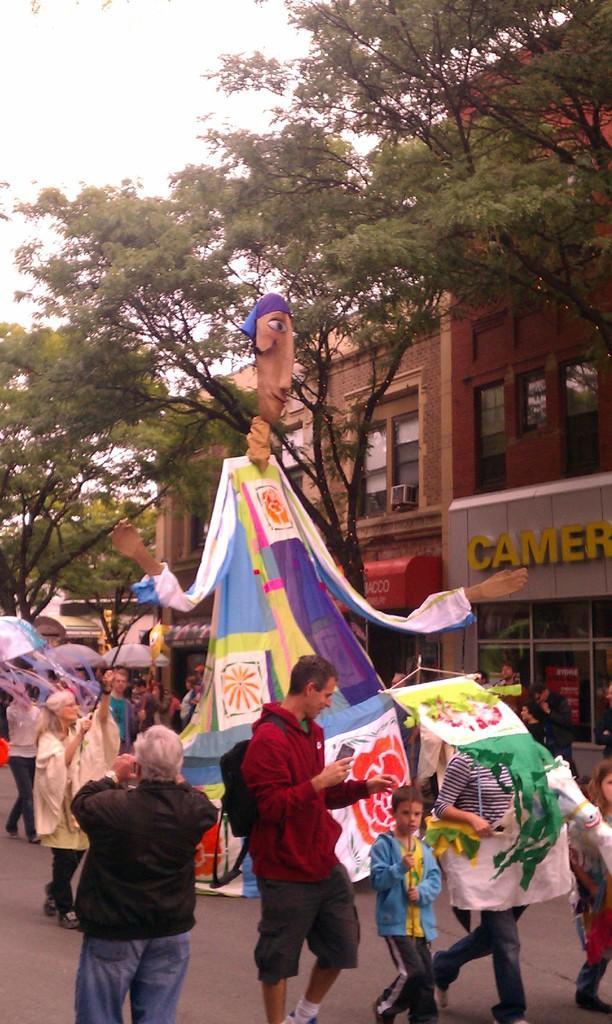Could you give a brief overview of what you see in this image? In the image in the center we can see one toy and cloth. And we can see few people were walking on the road and they were holding some objects. In the background we can see the sky,clouds,trees,buildings,banners,umbrellas,wall,glass etc. 